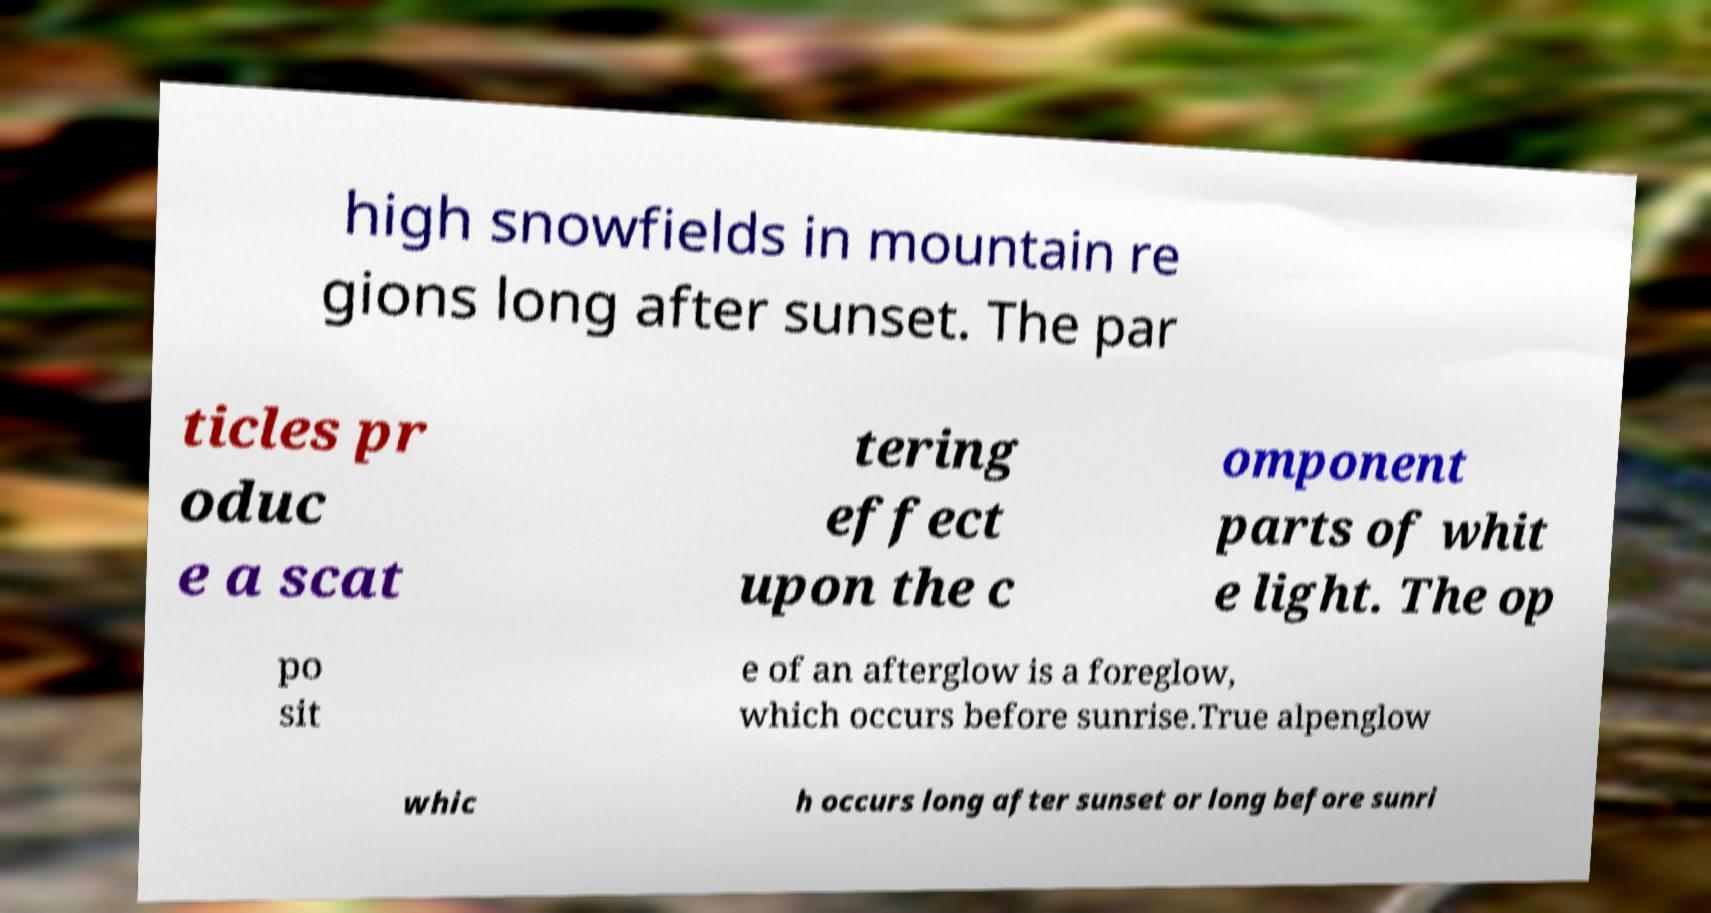I need the written content from this picture converted into text. Can you do that? high snowfields in mountain re gions long after sunset. The par ticles pr oduc e a scat tering effect upon the c omponent parts of whit e light. The op po sit e of an afterglow is a foreglow, which occurs before sunrise.True alpenglow whic h occurs long after sunset or long before sunri 